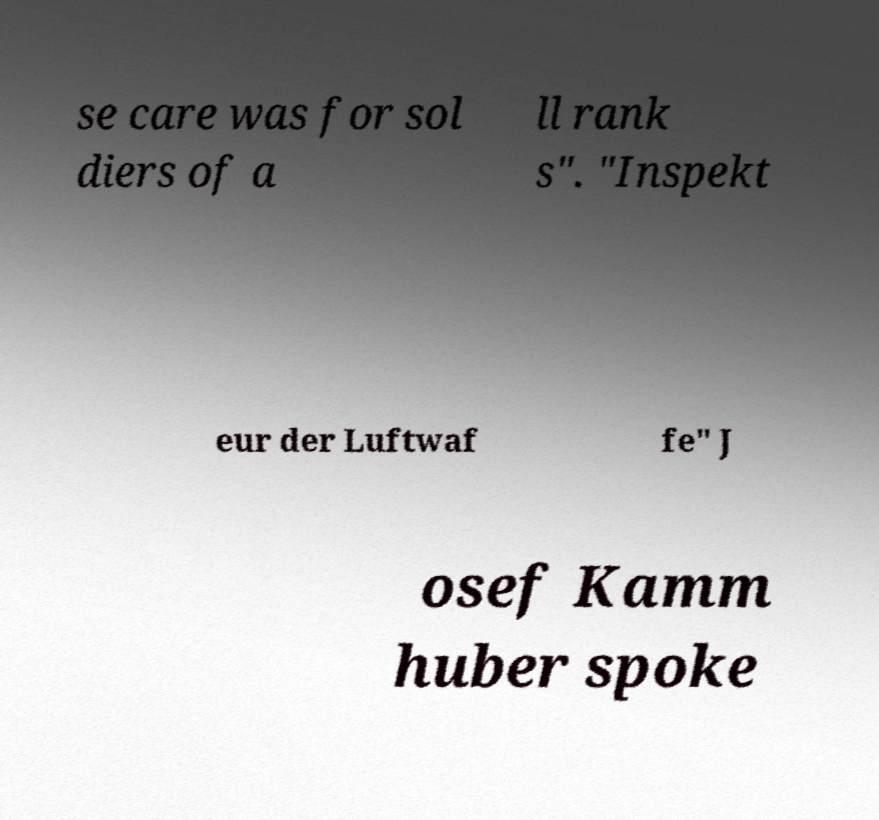I need the written content from this picture converted into text. Can you do that? se care was for sol diers of a ll rank s". "Inspekt eur der Luftwaf fe" J osef Kamm huber spoke 